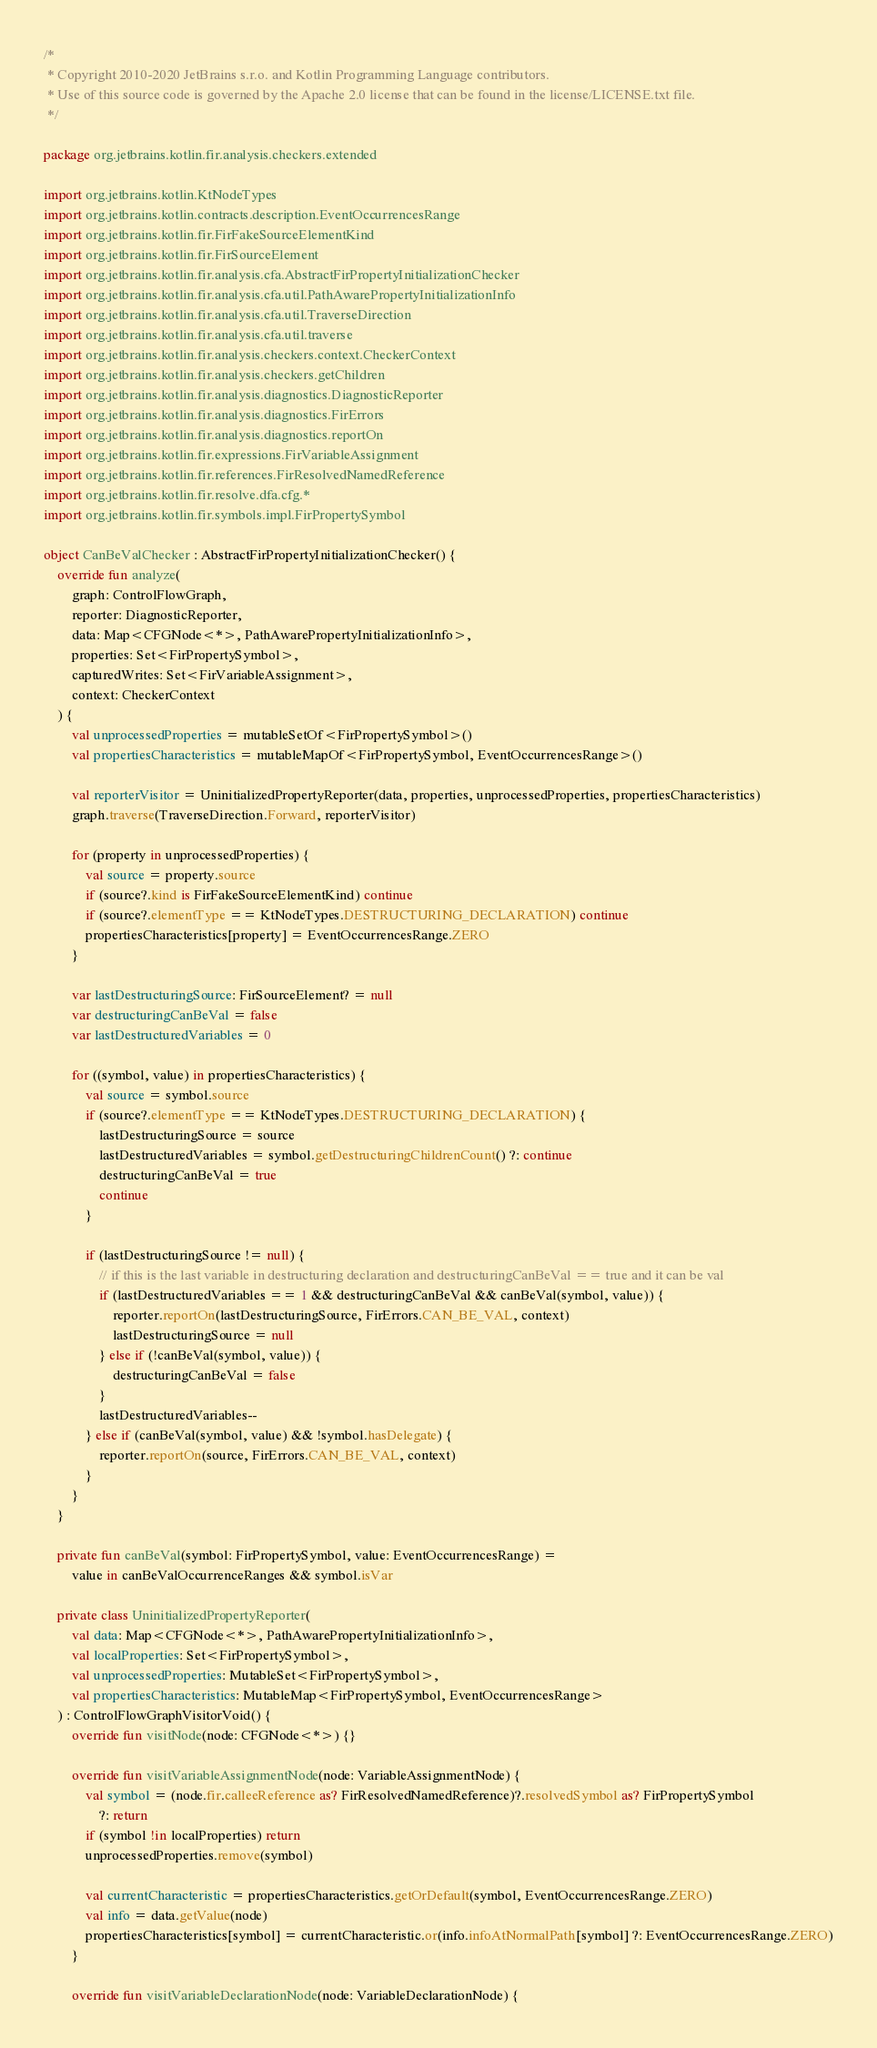Convert code to text. <code><loc_0><loc_0><loc_500><loc_500><_Kotlin_>/*
 * Copyright 2010-2020 JetBrains s.r.o. and Kotlin Programming Language contributors.
 * Use of this source code is governed by the Apache 2.0 license that can be found in the license/LICENSE.txt file.
 */

package org.jetbrains.kotlin.fir.analysis.checkers.extended

import org.jetbrains.kotlin.KtNodeTypes
import org.jetbrains.kotlin.contracts.description.EventOccurrencesRange
import org.jetbrains.kotlin.fir.FirFakeSourceElementKind
import org.jetbrains.kotlin.fir.FirSourceElement
import org.jetbrains.kotlin.fir.analysis.cfa.AbstractFirPropertyInitializationChecker
import org.jetbrains.kotlin.fir.analysis.cfa.util.PathAwarePropertyInitializationInfo
import org.jetbrains.kotlin.fir.analysis.cfa.util.TraverseDirection
import org.jetbrains.kotlin.fir.analysis.cfa.util.traverse
import org.jetbrains.kotlin.fir.analysis.checkers.context.CheckerContext
import org.jetbrains.kotlin.fir.analysis.checkers.getChildren
import org.jetbrains.kotlin.fir.analysis.diagnostics.DiagnosticReporter
import org.jetbrains.kotlin.fir.analysis.diagnostics.FirErrors
import org.jetbrains.kotlin.fir.analysis.diagnostics.reportOn
import org.jetbrains.kotlin.fir.expressions.FirVariableAssignment
import org.jetbrains.kotlin.fir.references.FirResolvedNamedReference
import org.jetbrains.kotlin.fir.resolve.dfa.cfg.*
import org.jetbrains.kotlin.fir.symbols.impl.FirPropertySymbol

object CanBeValChecker : AbstractFirPropertyInitializationChecker() {
    override fun analyze(
        graph: ControlFlowGraph,
        reporter: DiagnosticReporter,
        data: Map<CFGNode<*>, PathAwarePropertyInitializationInfo>,
        properties: Set<FirPropertySymbol>,
        capturedWrites: Set<FirVariableAssignment>,
        context: CheckerContext
    ) {
        val unprocessedProperties = mutableSetOf<FirPropertySymbol>()
        val propertiesCharacteristics = mutableMapOf<FirPropertySymbol, EventOccurrencesRange>()

        val reporterVisitor = UninitializedPropertyReporter(data, properties, unprocessedProperties, propertiesCharacteristics)
        graph.traverse(TraverseDirection.Forward, reporterVisitor)

        for (property in unprocessedProperties) {
            val source = property.source
            if (source?.kind is FirFakeSourceElementKind) continue
            if (source?.elementType == KtNodeTypes.DESTRUCTURING_DECLARATION) continue
            propertiesCharacteristics[property] = EventOccurrencesRange.ZERO
        }

        var lastDestructuringSource: FirSourceElement? = null
        var destructuringCanBeVal = false
        var lastDestructuredVariables = 0

        for ((symbol, value) in propertiesCharacteristics) {
            val source = symbol.source
            if (source?.elementType == KtNodeTypes.DESTRUCTURING_DECLARATION) {
                lastDestructuringSource = source
                lastDestructuredVariables = symbol.getDestructuringChildrenCount() ?: continue
                destructuringCanBeVal = true
                continue
            }

            if (lastDestructuringSource != null) {
                // if this is the last variable in destructuring declaration and destructuringCanBeVal == true and it can be val
                if (lastDestructuredVariables == 1 && destructuringCanBeVal && canBeVal(symbol, value)) {
                    reporter.reportOn(lastDestructuringSource, FirErrors.CAN_BE_VAL, context)
                    lastDestructuringSource = null
                } else if (!canBeVal(symbol, value)) {
                    destructuringCanBeVal = false
                }
                lastDestructuredVariables--
            } else if (canBeVal(symbol, value) && !symbol.hasDelegate) {
                reporter.reportOn(source, FirErrors.CAN_BE_VAL, context)
            }
        }
    }

    private fun canBeVal(symbol: FirPropertySymbol, value: EventOccurrencesRange) =
        value in canBeValOccurrenceRanges && symbol.isVar

    private class UninitializedPropertyReporter(
        val data: Map<CFGNode<*>, PathAwarePropertyInitializationInfo>,
        val localProperties: Set<FirPropertySymbol>,
        val unprocessedProperties: MutableSet<FirPropertySymbol>,
        val propertiesCharacteristics: MutableMap<FirPropertySymbol, EventOccurrencesRange>
    ) : ControlFlowGraphVisitorVoid() {
        override fun visitNode(node: CFGNode<*>) {}

        override fun visitVariableAssignmentNode(node: VariableAssignmentNode) {
            val symbol = (node.fir.calleeReference as? FirResolvedNamedReference)?.resolvedSymbol as? FirPropertySymbol
                ?: return
            if (symbol !in localProperties) return
            unprocessedProperties.remove(symbol)

            val currentCharacteristic = propertiesCharacteristics.getOrDefault(symbol, EventOccurrencesRange.ZERO)
            val info = data.getValue(node)
            propertiesCharacteristics[symbol] = currentCharacteristic.or(info.infoAtNormalPath[symbol] ?: EventOccurrencesRange.ZERO)
        }

        override fun visitVariableDeclarationNode(node: VariableDeclarationNode) {</code> 